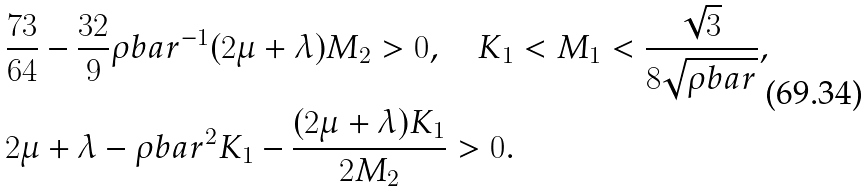Convert formula to latex. <formula><loc_0><loc_0><loc_500><loc_500>& \frac { 7 3 } { 6 4 } - \frac { 3 2 } { 9 } \rho b a r ^ { - 1 } ( 2 \mu + \lambda ) M _ { 2 } > 0 , \quad K _ { 1 } < M _ { 1 } < \frac { \sqrt { 3 } } { 8 \sqrt { \rho b a r } } , \\ & 2 \mu + \lambda - \rho b a r ^ { 2 } K _ { 1 } - \frac { ( 2 \mu + \lambda ) K _ { 1 } } { 2 M _ { 2 } } > 0 .</formula> 